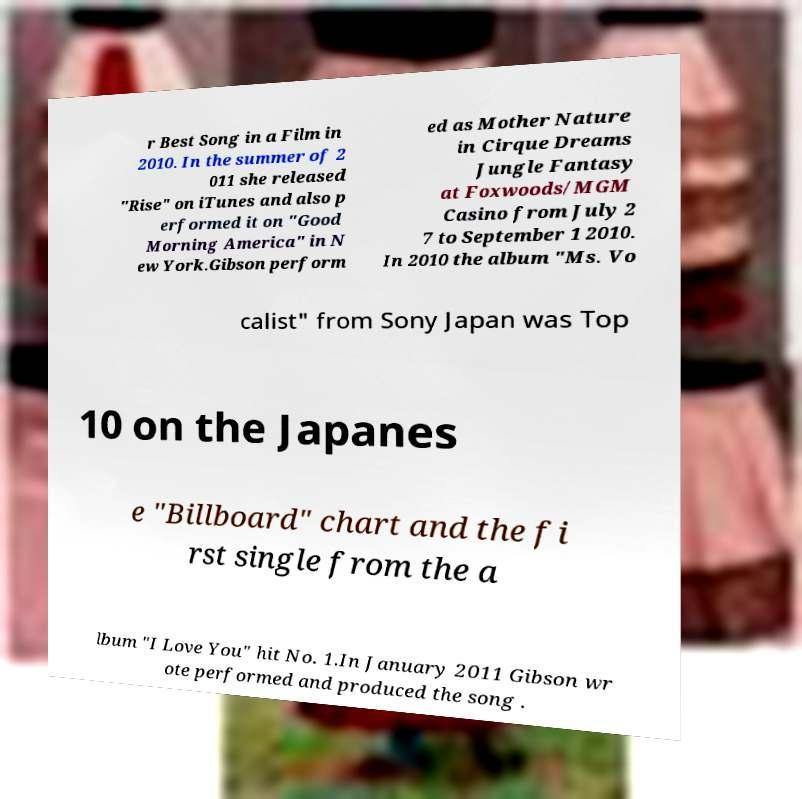Could you assist in decoding the text presented in this image and type it out clearly? r Best Song in a Film in 2010. In the summer of 2 011 she released "Rise" on iTunes and also p erformed it on "Good Morning America" in N ew York.Gibson perform ed as Mother Nature in Cirque Dreams Jungle Fantasy at Foxwoods/MGM Casino from July 2 7 to September 1 2010. In 2010 the album "Ms. Vo calist" from Sony Japan was Top 10 on the Japanes e "Billboard" chart and the fi rst single from the a lbum "I Love You" hit No. 1.In January 2011 Gibson wr ote performed and produced the song . 